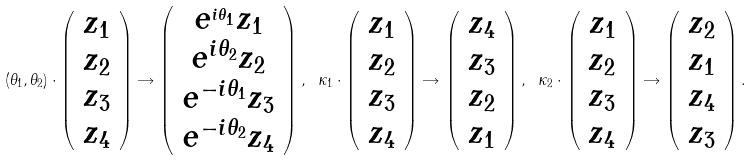Convert formula to latex. <formula><loc_0><loc_0><loc_500><loc_500>( \theta _ { 1 } , \theta _ { 2 } ) \cdot \left ( \begin{array} { c } z _ { 1 } \\ z _ { 2 } \\ z _ { 3 } \\ z _ { 4 } \end{array} \right ) \rightarrow \left ( \begin{array} { c } e ^ { _ { i \theta _ { 1 } } } z _ { 1 } \\ e ^ { i \theta _ { 2 } } z _ { 2 } \\ e ^ { - i \theta _ { 1 } } z _ { 3 } \\ e ^ { - i \theta _ { 2 } } z _ { 4 } \end{array} \right ) , \ \kappa _ { 1 } \cdot \left ( \begin{array} { c } z _ { 1 } \\ z _ { 2 } \\ z _ { 3 } \\ z _ { 4 } \end{array} \right ) \rightarrow \left ( \begin{array} { c } z _ { 4 } \\ z _ { 3 } \\ z _ { 2 } \\ z _ { 1 } \end{array} \right ) , \ \kappa _ { 2 } \cdot \left ( \begin{array} { c } z _ { 1 } \\ z _ { 2 } \\ z _ { 3 } \\ z _ { 4 } \end{array} \right ) \rightarrow \left ( \begin{array} { c } z _ { 2 } \\ z _ { 1 } \\ z _ { 4 } \\ z _ { 3 } \end{array} \right ) .</formula> 